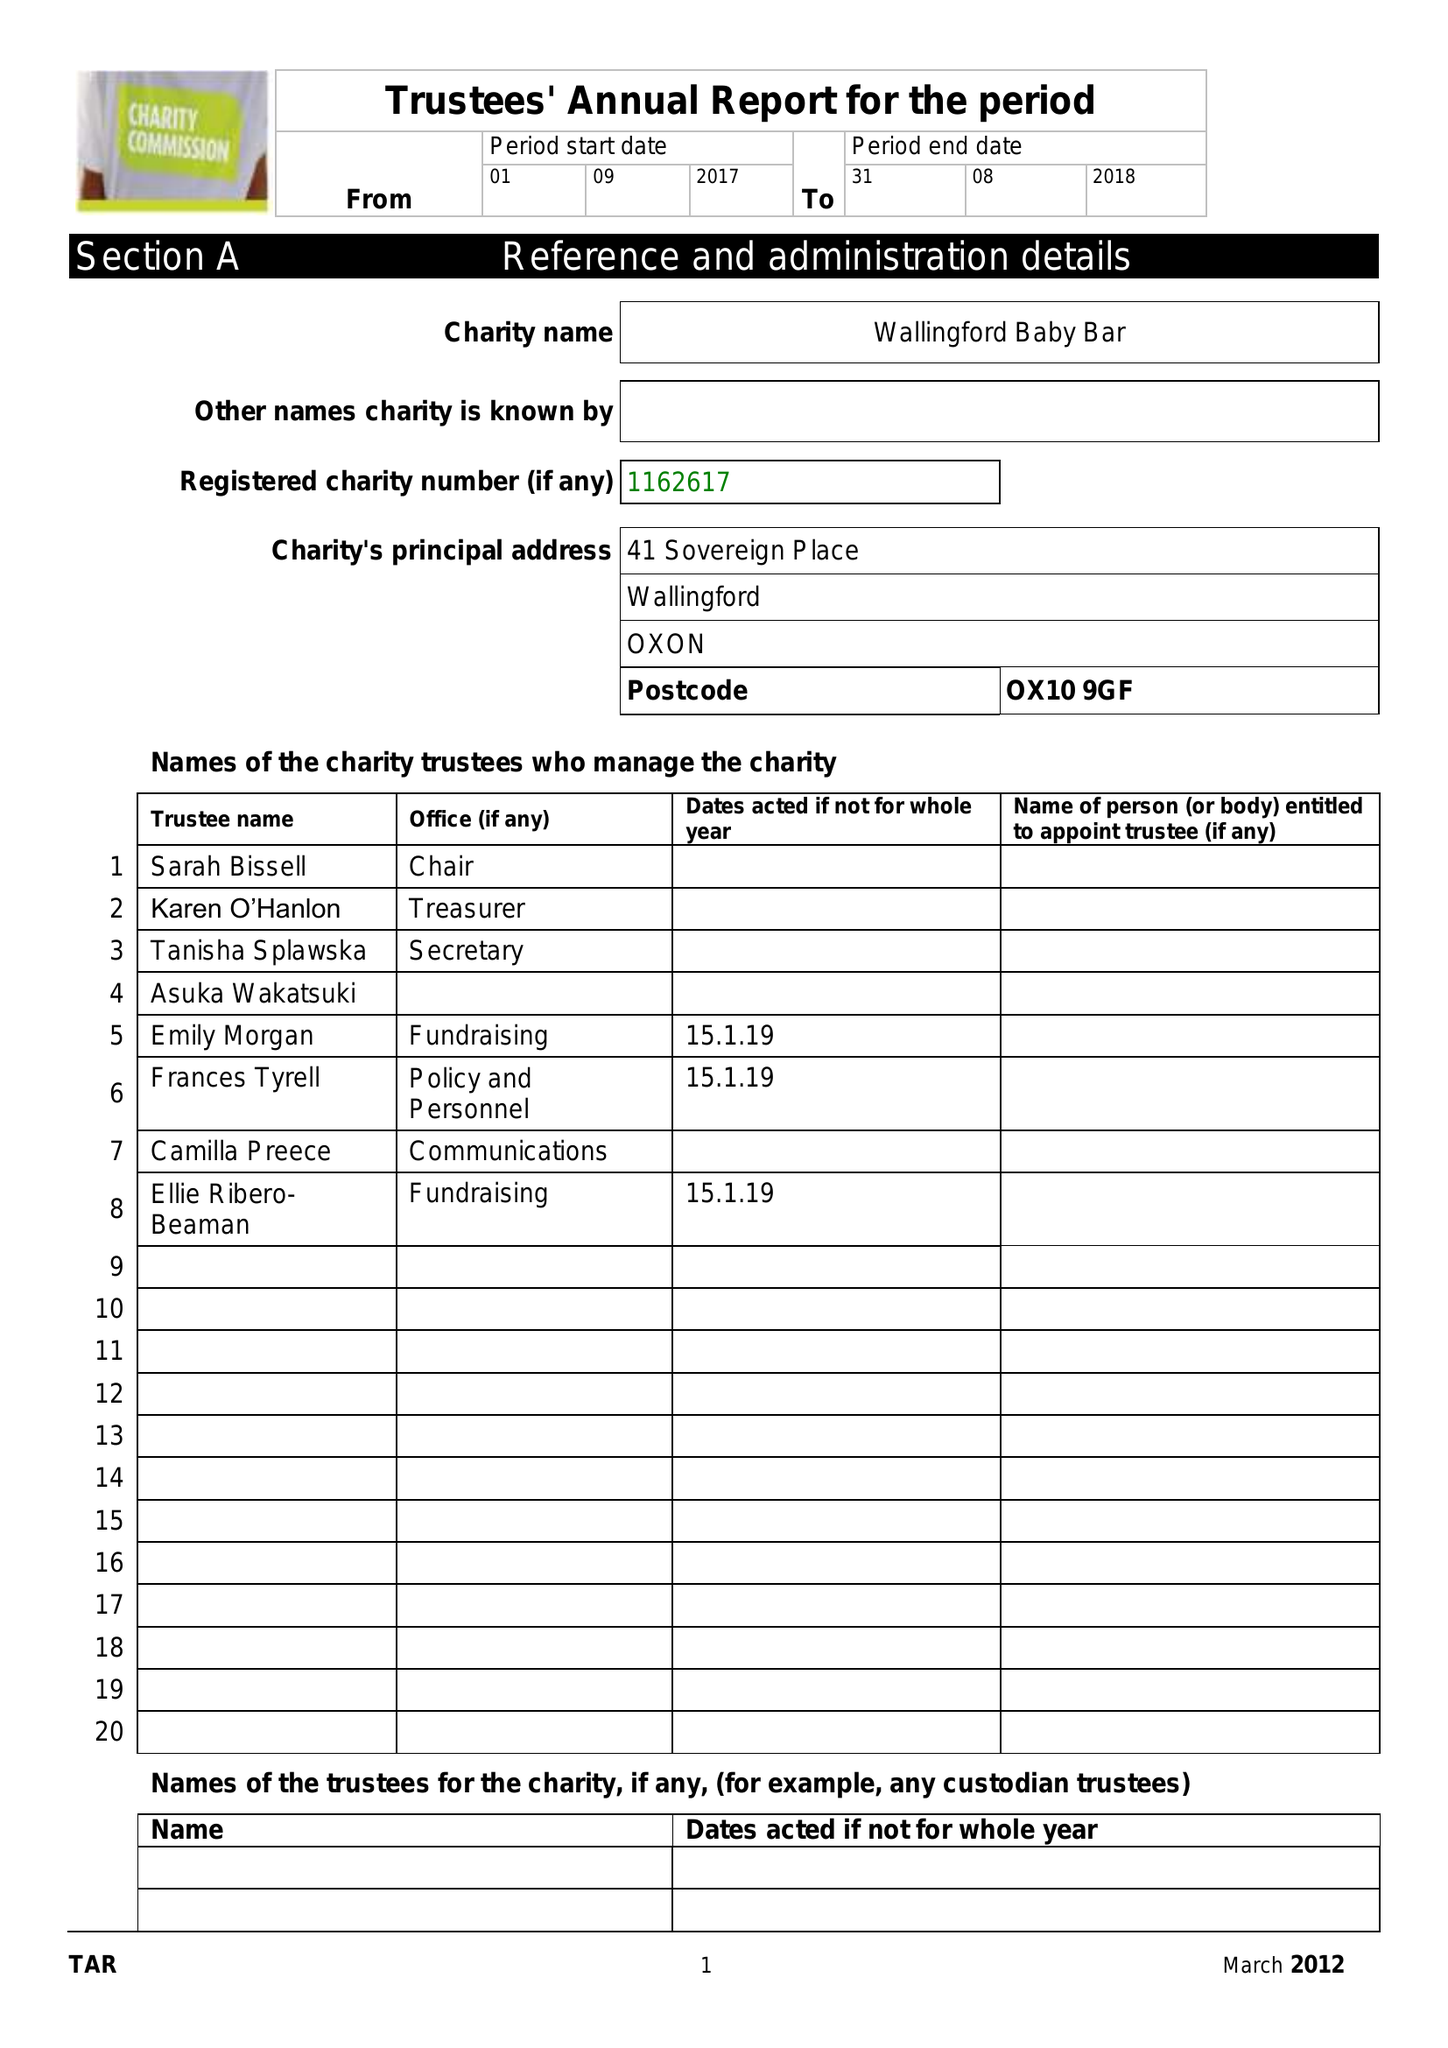What is the value for the spending_annually_in_british_pounds?
Answer the question using a single word or phrase. 5484.00 